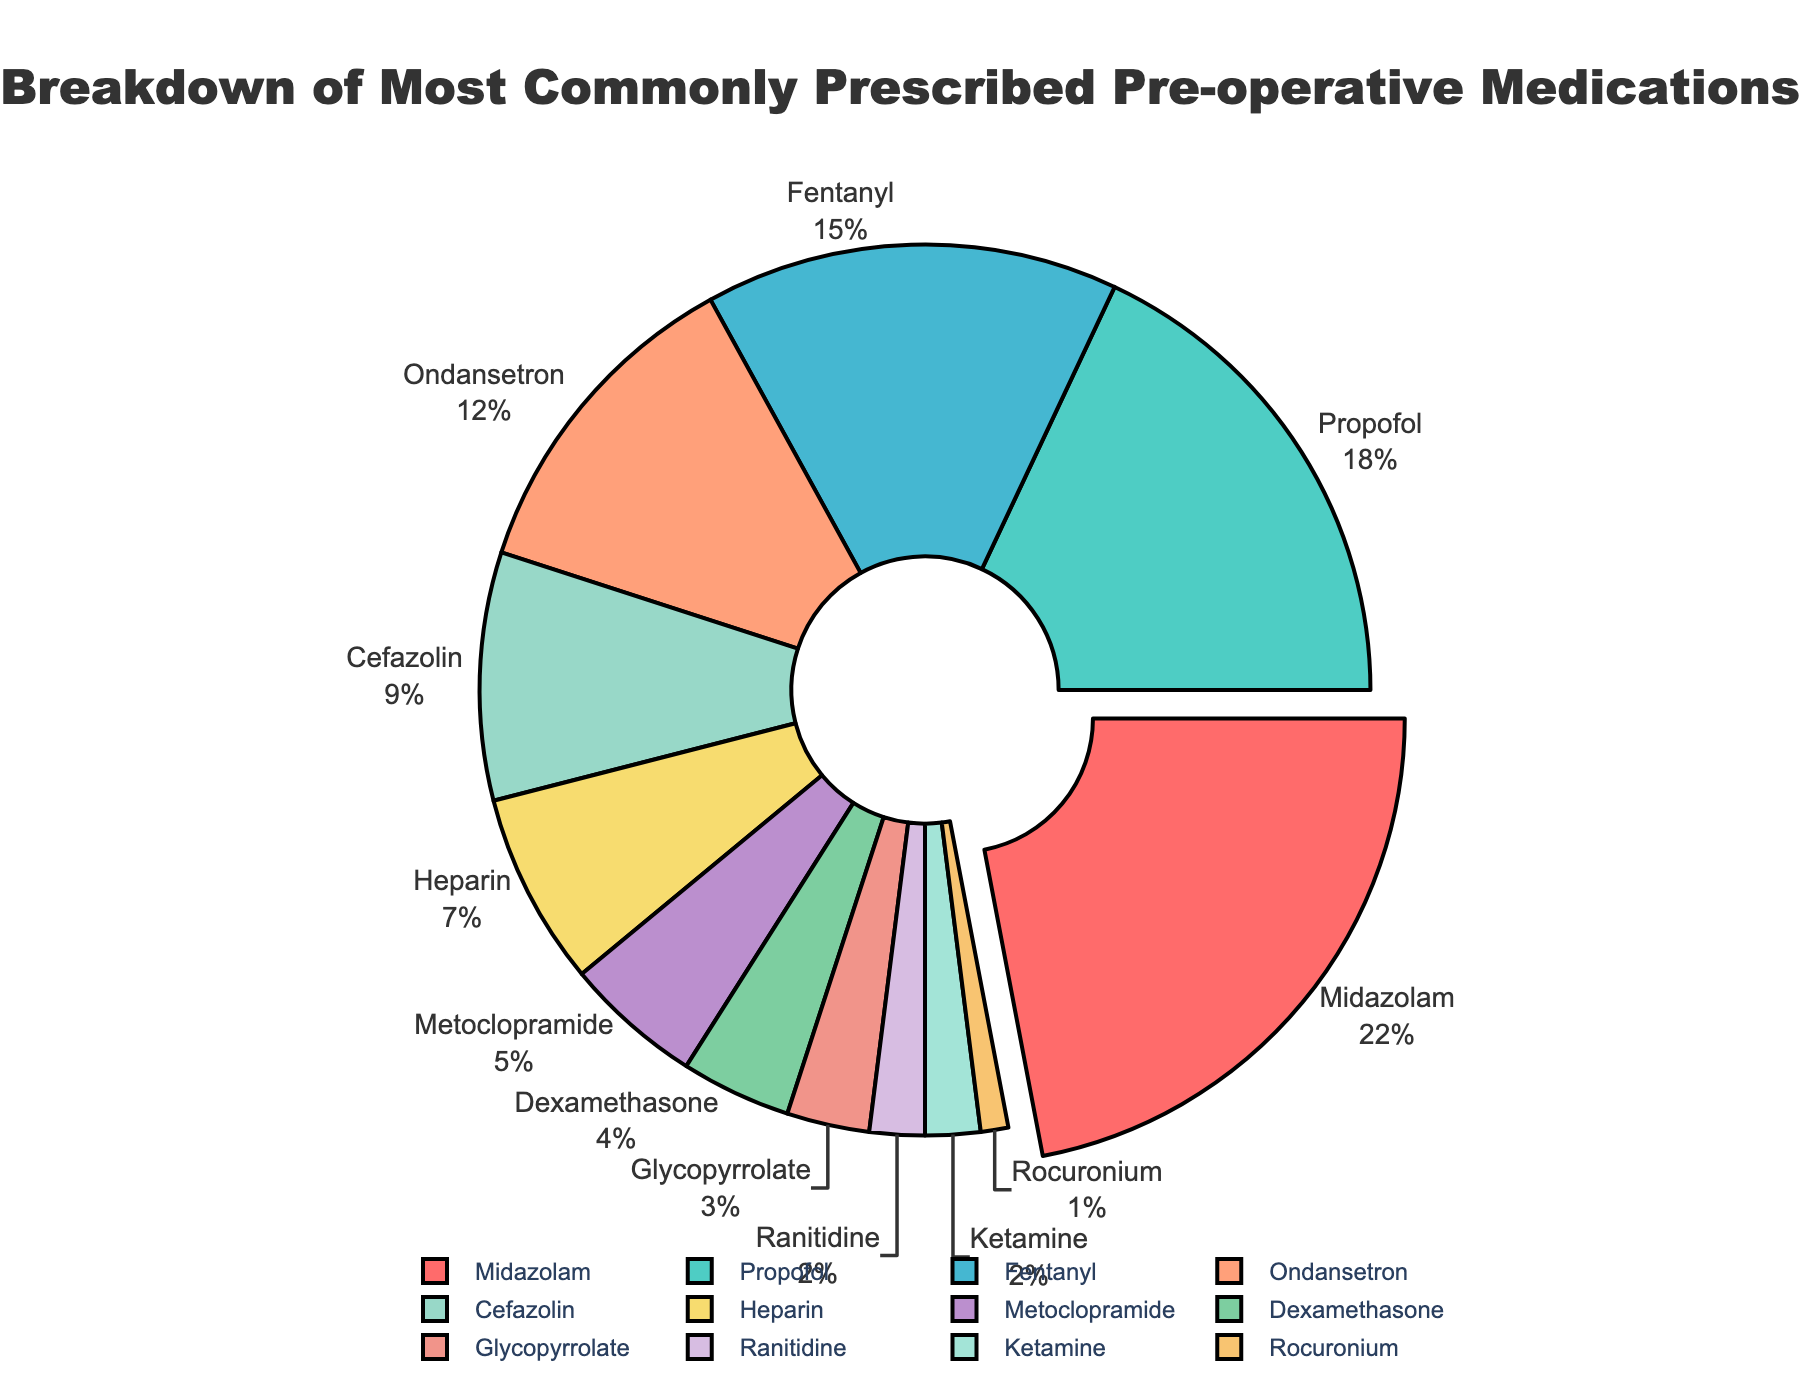Which medication has the highest percentage of usage in pre-operative procedures? To determine which medication has the highest percentage of usage, look for the segment that is pulled out and also has the largest size. The segment for Midazolam is pulled out and corresponds to 22%.
Answer: Midazolam What is the total percentage of the top three prescribed medications? Sum the percentages of the top three medications: Midazolam (22%), Propofol (18%), and Fentanyl (15%). \(22 + 18 + 15 = 55\%\)
Answer: 55% Which medication is prescribed the least and what is its percentage? Identify the segment with the smallest size. Rocuronium is the smallest and has a percentage of 1%.
Answer: Rocuronium, 1% How many medications are prescribed with a percentage less than 5%? Count the segments with percentages less than 5%: Metoclopramide (5%), Dexamethasone (4%), Glycopyrrolate (3%), Ranitidine (2%), Ketamine (2%), and Rocuronium (1%). There are four segments.
Answer: Six How much more is the percentage of Midazolam compared to Fentanyl? Find the difference between the percentages of Midazolam and Fentanyl: \(22 - 15 = 7\%\)
Answer: 7% What is the average percentage of Ondansetron, Cefazolin, and Heparin? Calculate the average of the three percentages: \(\frac{12 + 9 + 7}{3} = 9.33\%\)
Answer: 9.33% What is the combined percentage of all medications except Midazolam? Subtract Midazolam's percentage from the total (100%): \(100 - 22 = 78\%\)
Answer: 78% Is the percentage of Cefazolin greater than half of the percentage of Propofol? Calculate half the percentage of Propofol: \(18 / 2 = 9\%\). Compare it to Cefazolin's 9%. They are equal.
Answer: Equal Which color is representing Propofol in the pie chart? Locate the segment with the label Propofol and identify its color. The color representing Propofol is teal or blue-green.
Answer: Teal or blue-green Compare the combined percentage of medications prescribed more than 10% to those prescribed less than 10%. Sum the percentages of medications greater than 10%: \(22 + 18 + 15 + 12 = 67\%\). Sum the rest: \(9 + 7 + 5 + 4 + 3 + 2 + 2 + 1 = 33\%\). Medications greater than 10% have a total of 67%, and less than 10% have 33%.
Answer: 67% and 33% 